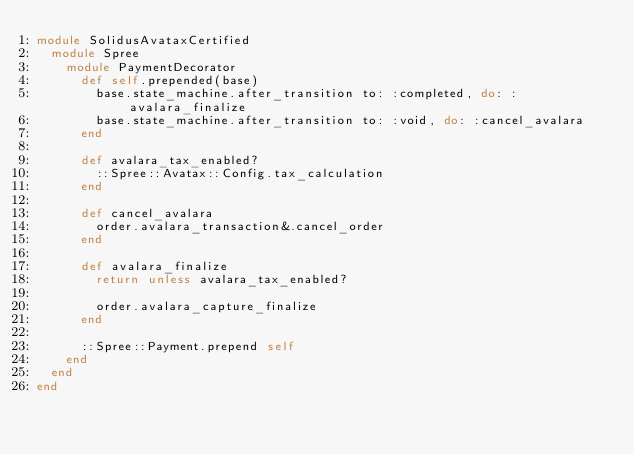Convert code to text. <code><loc_0><loc_0><loc_500><loc_500><_Ruby_>module SolidusAvataxCertified
  module Spree
    module PaymentDecorator
      def self.prepended(base)
        base.state_machine.after_transition to: :completed, do: :avalara_finalize
        base.state_machine.after_transition to: :void, do: :cancel_avalara
      end

      def avalara_tax_enabled?
        ::Spree::Avatax::Config.tax_calculation
      end

      def cancel_avalara
        order.avalara_transaction&.cancel_order
      end

      def avalara_finalize
        return unless avalara_tax_enabled?

        order.avalara_capture_finalize
      end

      ::Spree::Payment.prepend self
    end
  end
end
</code> 